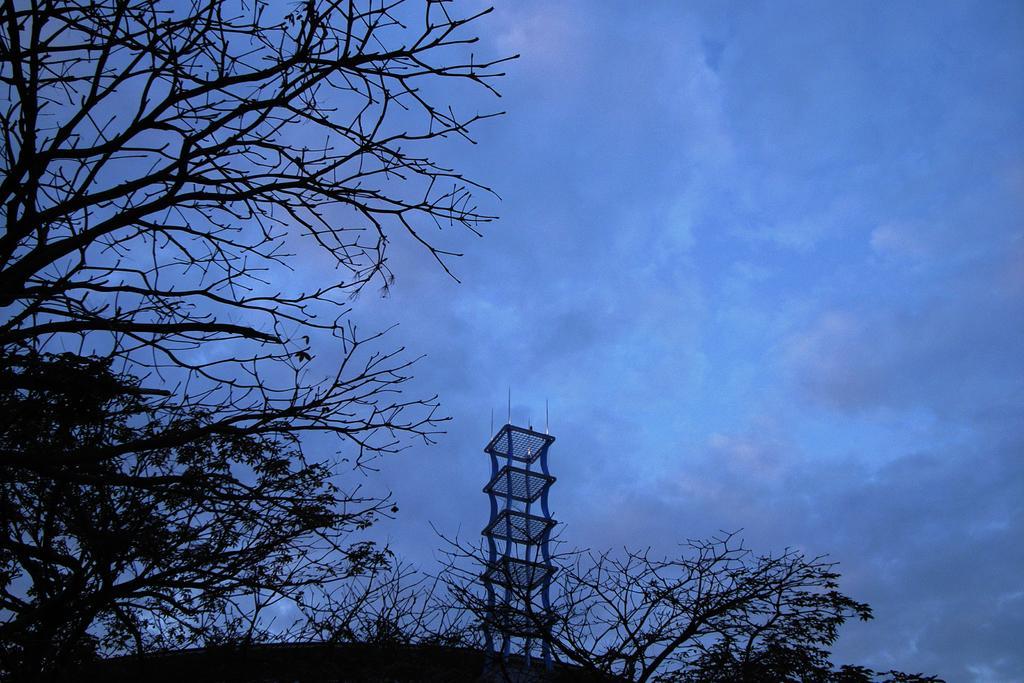Describe this image in one or two sentences. In the picture I can see the deciduous trees on the left side. There is a tower construction at the bottom of the picture. There are clouds in the sky. 